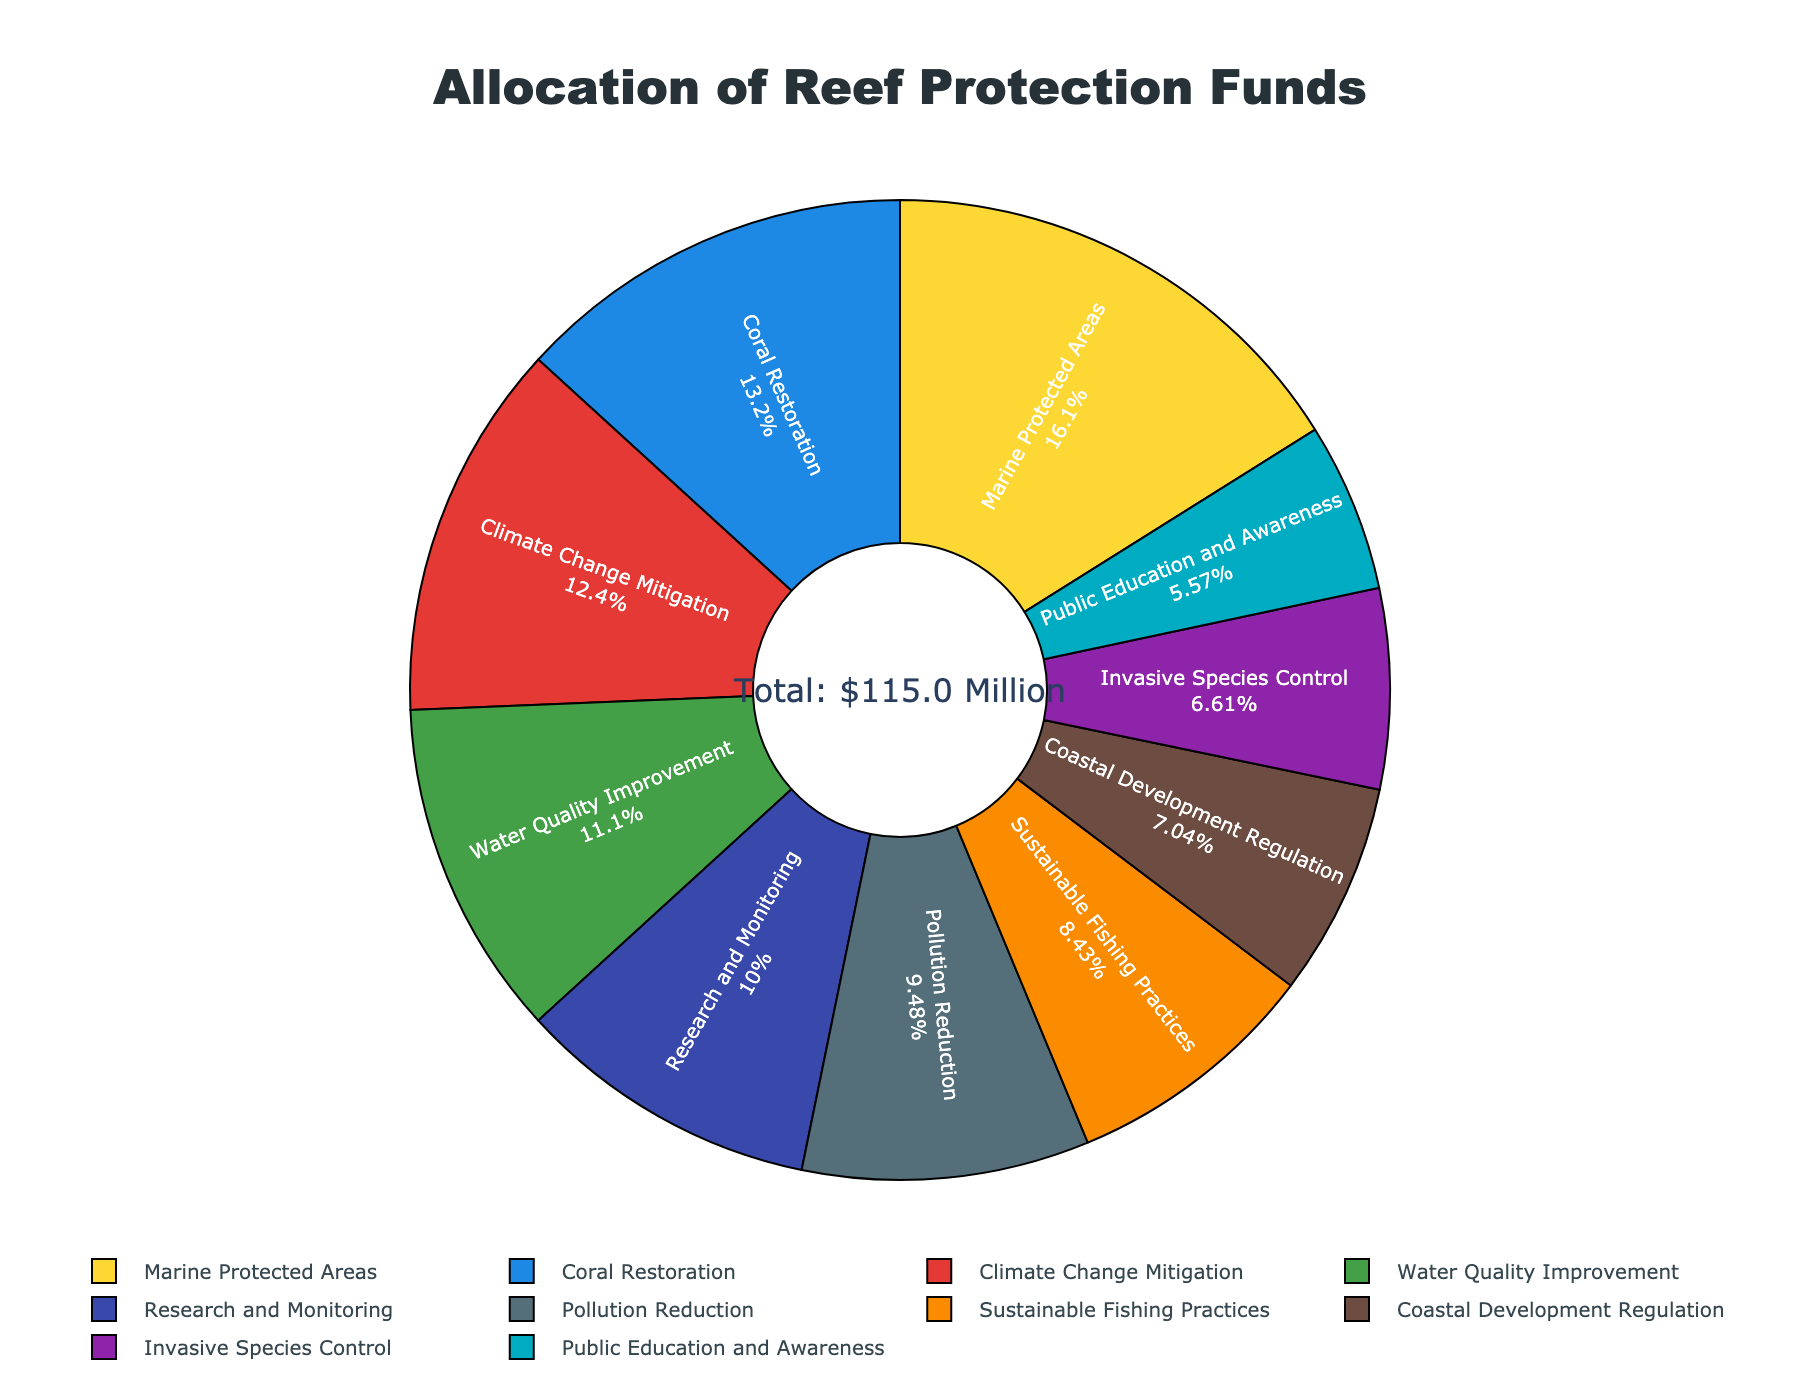What percentage of the funds is allocated to Marine Protected Areas? Locate Marine Protected Areas in the pie chart and refer to the percentage label next to it. The label shows the percentage of total funds allocated to this strategy.
Answer: 18.5% Which strategy received the least funding and how much was it? Identify the smallest segment in the pie chart, which represents the strategy with the least funding. Then, refer to the label for that segment to find the allocated amount.
Answer: Public Education and Awareness received $6.4 million What is the difference in funding between Coral Restoration and Climate Change Mitigation? Find the allocated amounts for both Coral Restoration ($15.2 million) and Climate Change Mitigation ($14.3 million). Subtract the smaller amount from the larger amount to find the difference: $15.2 million - $14.3 million = $0.9 million.
Answer: $0.9 million Which strategies combined account for more than 50% of the total funding? List them. Check the segments in the pie chart and sum their percentages until the total exceeds 50%. Marine Protected Areas (18.5%), Coral Restoration (15.2%), Climate Change Mitigation (14.3%), and Water Quality Improvement (12.8%) together contribute more than 50%.
Answer: Marine Protected Areas, Coral Restoration, Climate Change Mitigation, and Water Quality Improvement Is the funding for Pollution Reduction more or less than the average funding allocated per strategy? First, calculate the total funds allocated ($115 million) and the number of strategies (10). The average funding per strategy is $115 million / 10 = $11.5 million. Since Pollution Reduction received $10.9 million, which is less than $11.5 million, it is below the average.
Answer: Less Which strategy uses the green color and how much funding was allocated to it? The green color in the pie chart corresponds to Water Quality Improvement. The label indicates that $12.8 million was allocated to this strategy.
Answer: Water Quality Improvement, $12.8 million What is the combined funding for Sustainable Fishing Practices, Coastal Development Regulation, and Invasive Species Control? Find the allocated amounts for Sustainable Fishing Practices ($9.7 million), Coastal Development Regulation ($8.1 million), and Invasive Species Control ($7.6 million). Sum these values: $9.7 million + $8.1 million + $7.6 million = $25.4 million.
Answer: $25.4 million How many strategies have received more than $10 million in funding? Find segments in the pie chart with labels indicating more than $10 million in funding. The strategies fulfilling this criterion are Coral Restoration, Water Quality Improvement, Marine Protected Areas, Climate Change Mitigation, Research and Monitoring, and Pollution Reduction. Count them: 6 strategies.
Answer: 6 